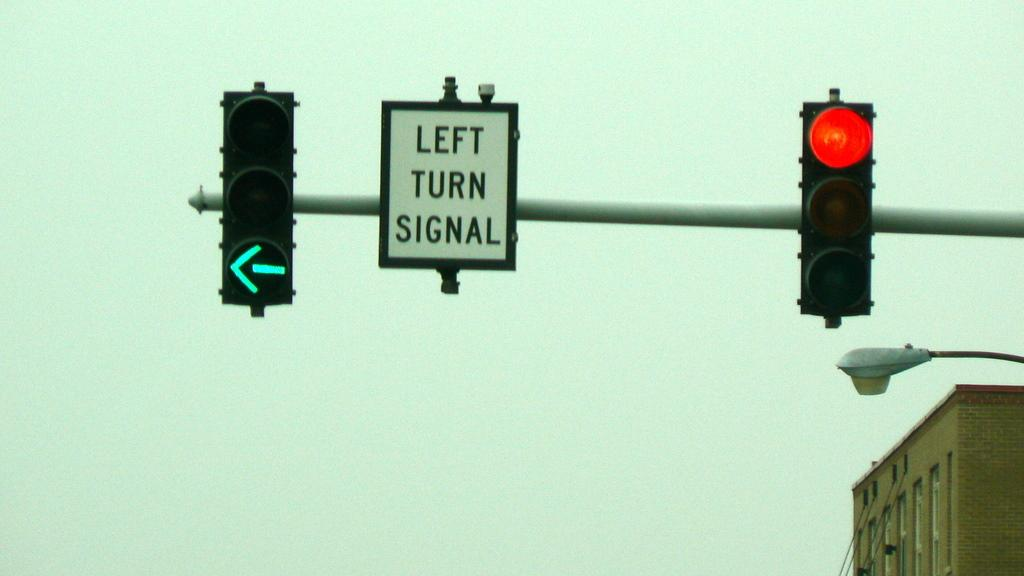<image>
Relay a brief, clear account of the picture shown. A street sign reads LEFT TURN SIGNAL in between one light red and the other one pointed to the left. 